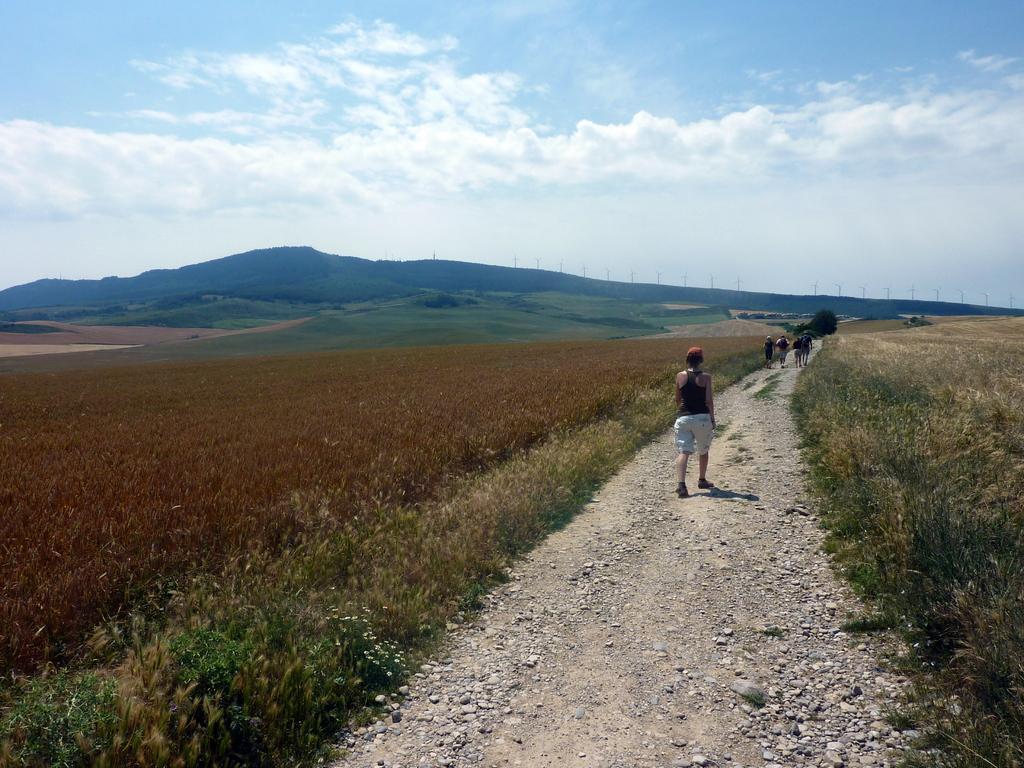Can you describe this image briefly? In the foreground of this image, there are few people walking on the path and on either side, there is grass. In the background, there is grassland, cliffs, wind fans and the sky. 